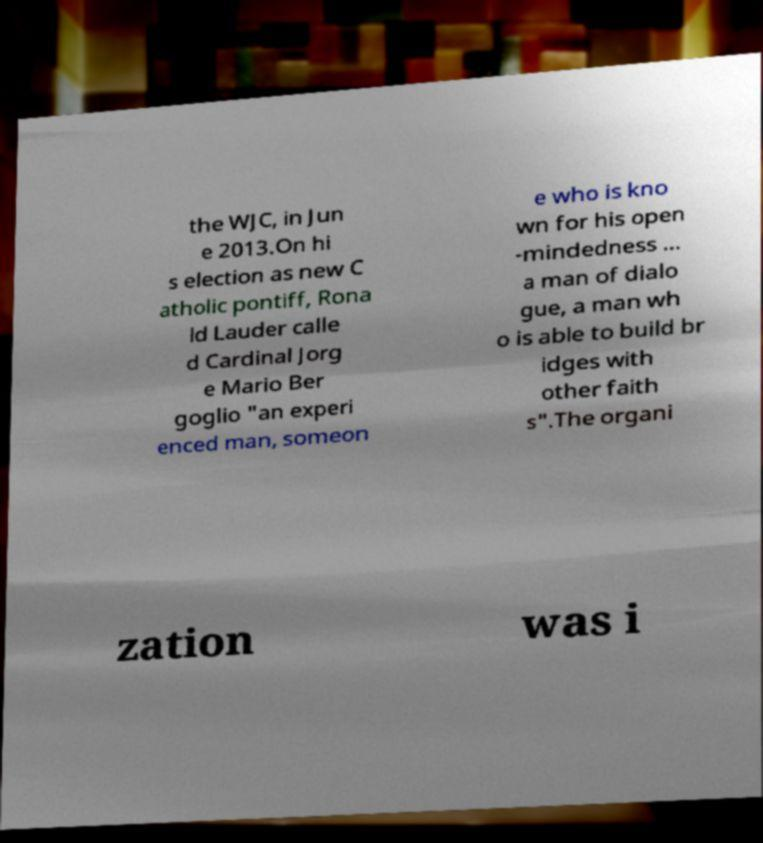Please read and relay the text visible in this image. What does it say? the WJC, in Jun e 2013.On hi s election as new C atholic pontiff, Rona ld Lauder calle d Cardinal Jorg e Mario Ber goglio "an experi enced man, someon e who is kno wn for his open -mindedness ... a man of dialo gue, a man wh o is able to build br idges with other faith s".The organi zation was i 